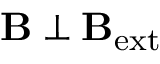<formula> <loc_0><loc_0><loc_500><loc_500>B \perp B _ { e x t }</formula> 